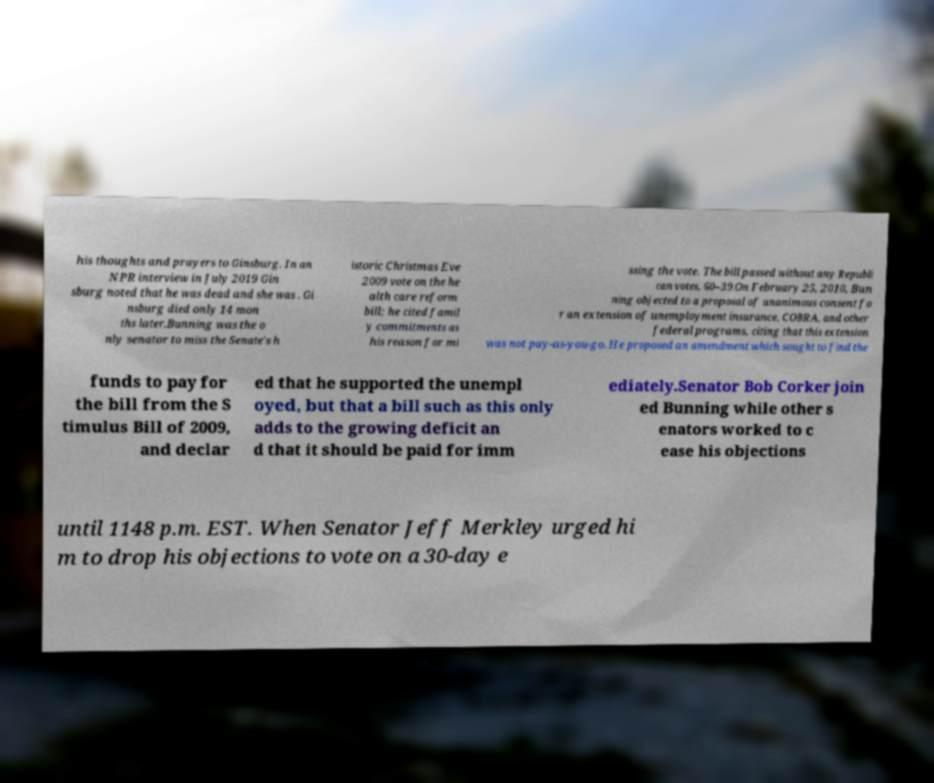Please read and relay the text visible in this image. What does it say? his thoughts and prayers to Ginsburg. In an NPR interview in July 2019 Gin sburg noted that he was dead and she was . Gi nsburg died only 14 mon ths later.Bunning was the o nly senator to miss the Senate's h istoric Christmas Eve 2009 vote on the he alth care reform bill; he cited famil y commitments as his reason for mi ssing the vote. The bill passed without any Republi can votes, 60–39.On February 25, 2010, Bun ning objected to a proposal of unanimous consent fo r an extension of unemployment insurance, COBRA, and other federal programs, citing that this extension was not pay-as-you-go. He proposed an amendment which sought to find the funds to pay for the bill from the S timulus Bill of 2009, and declar ed that he supported the unempl oyed, but that a bill such as this only adds to the growing deficit an d that it should be paid for imm ediately.Senator Bob Corker join ed Bunning while other s enators worked to c ease his objections until 1148 p.m. EST. When Senator Jeff Merkley urged hi m to drop his objections to vote on a 30-day e 